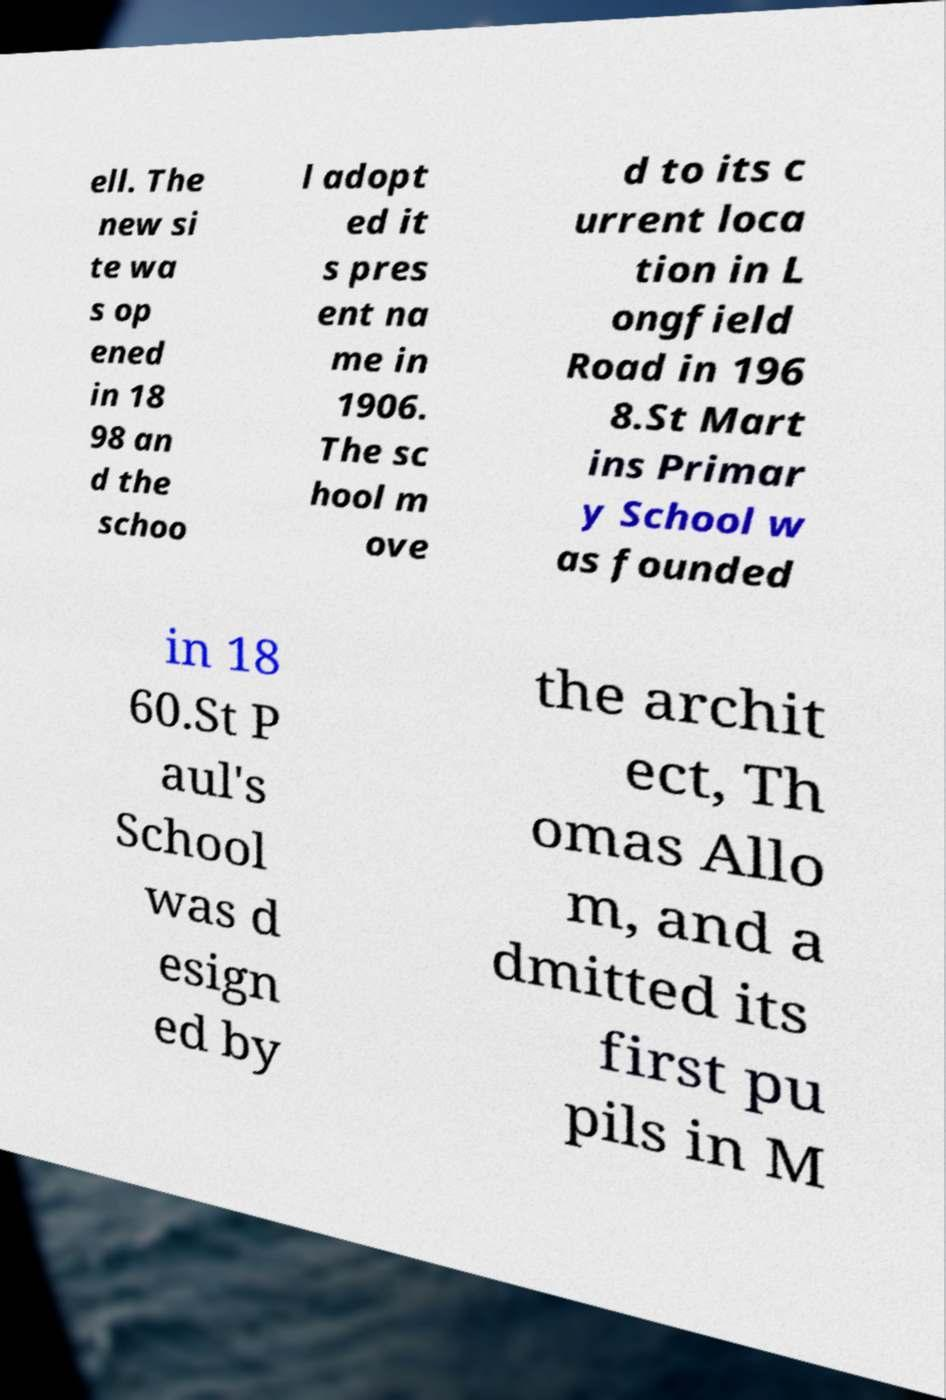There's text embedded in this image that I need extracted. Can you transcribe it verbatim? ell. The new si te wa s op ened in 18 98 an d the schoo l adopt ed it s pres ent na me in 1906. The sc hool m ove d to its c urrent loca tion in L ongfield Road in 196 8.St Mart ins Primar y School w as founded in 18 60.St P aul's School was d esign ed by the archit ect, Th omas Allo m, and a dmitted its first pu pils in M 